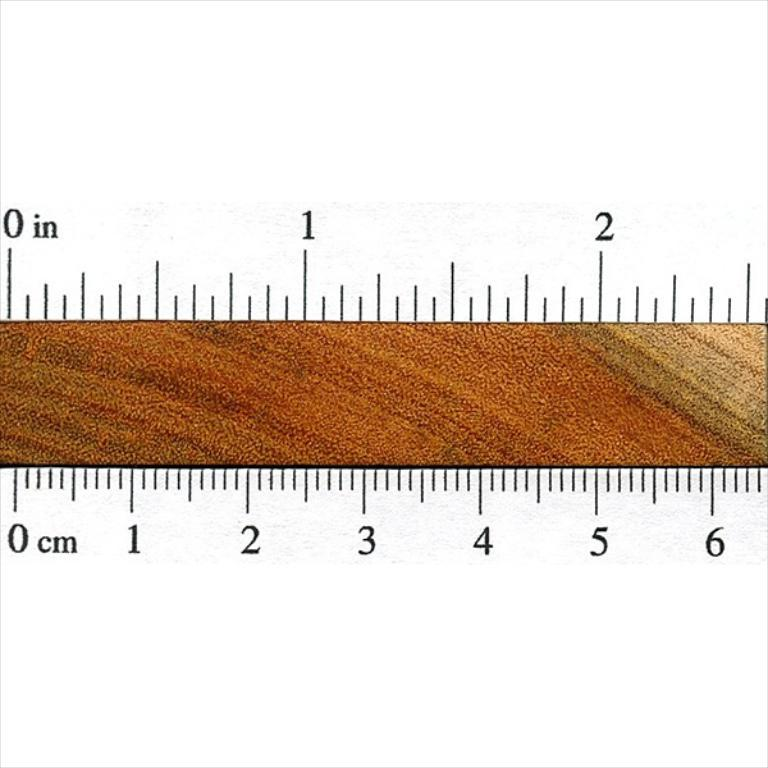<image>
Present a compact description of the photo's key features. A brown ruler measures at least 6 centimeters. 